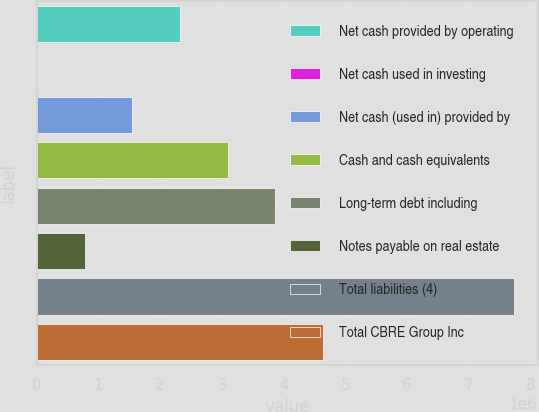<chart> <loc_0><loc_0><loc_500><loc_500><bar_chart><fcel>Net cash provided by operating<fcel>Net cash used in investing<fcel>Net cash (used in) provided by<fcel>Cash and cash equivalents<fcel>Long-term debt including<fcel>Notes payable on real estate<fcel>Total liabilities (4)<fcel>Total CBRE Group Inc<nl><fcel>2.32191e+06<fcel>7439<fcel>1.55042e+06<fcel>3.0934e+06<fcel>3.86489e+06<fcel>778929<fcel>7.72234e+06<fcel>4.63638e+06<nl></chart> 